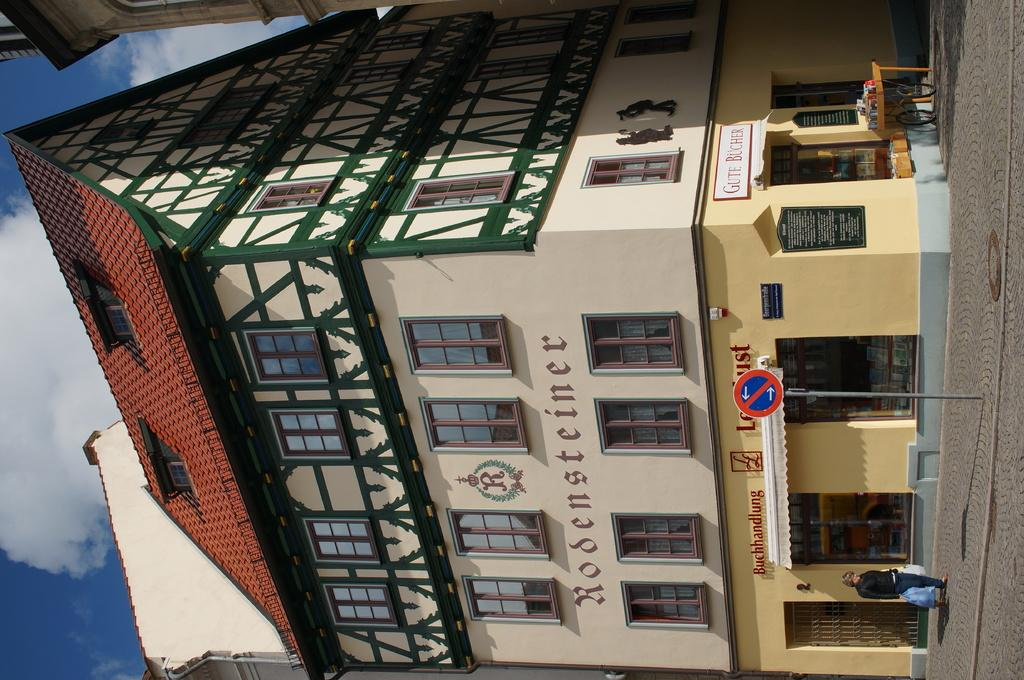What is the person in the image doing? The person is holding bags in the image. Where is the person standing? The person is standing on the road. What can be seen in the image besides the person? There is a pole, a sign board, a table, buildings, windows, and some objects in the image. What is visible in the background of the image? The sky is visible in the background of the image. How many snails can be seen crawling on the table in the image? There are no snails visible in the image. What type of cattle is present in the image? There are no cattle present in the image. 